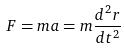Convert formula to latex. <formula><loc_0><loc_0><loc_500><loc_500>F = m a = m \frac { d ^ { 2 } r } { d t ^ { 2 } }</formula> 